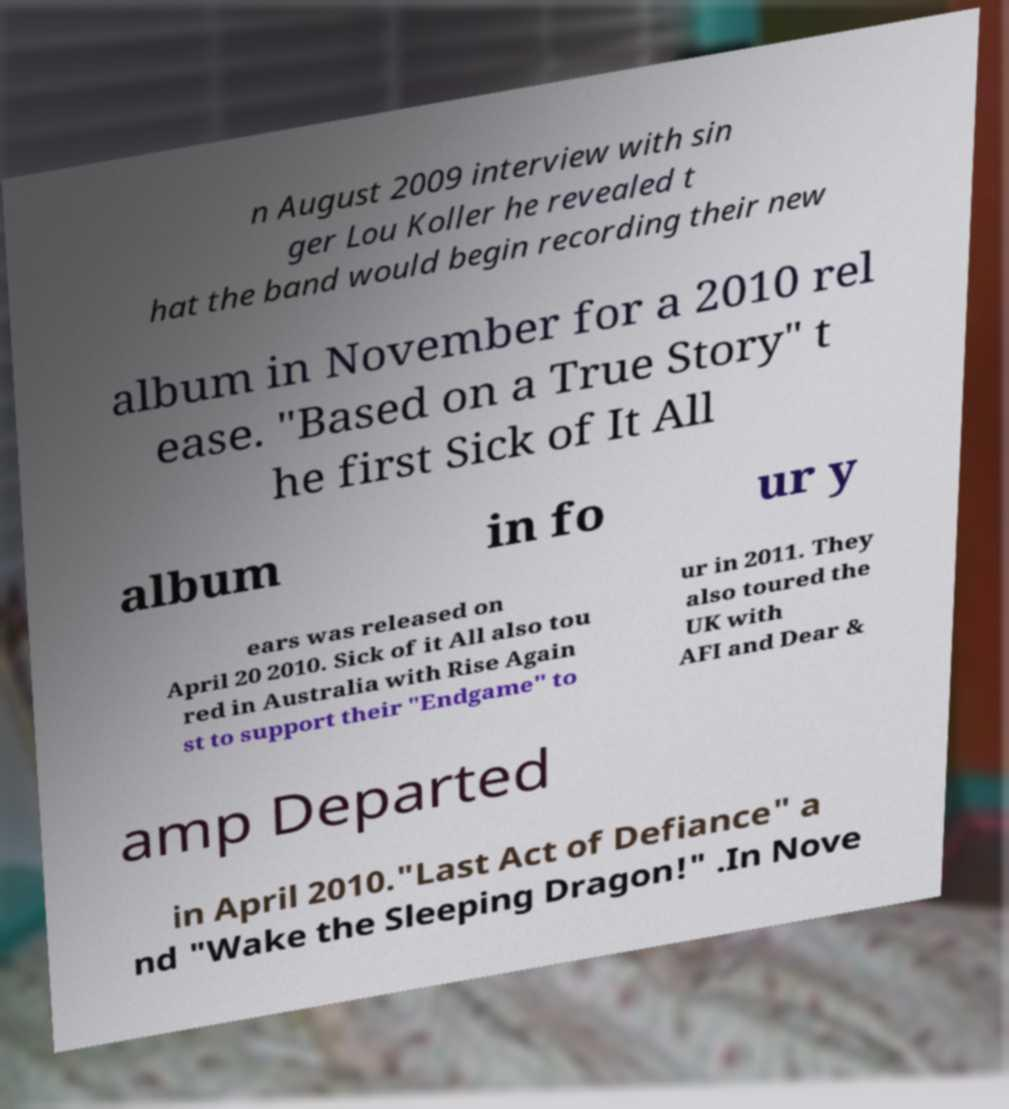Could you extract and type out the text from this image? n August 2009 interview with sin ger Lou Koller he revealed t hat the band would begin recording their new album in November for a 2010 rel ease. "Based on a True Story" t he first Sick of It All album in fo ur y ears was released on April 20 2010. Sick of it All also tou red in Australia with Rise Again st to support their "Endgame" to ur in 2011. They also toured the UK with AFI and Dear & amp Departed in April 2010."Last Act of Defiance" a nd "Wake the Sleeping Dragon!" .In Nove 